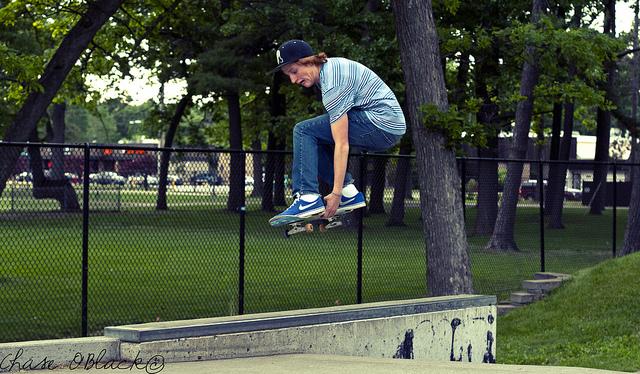Is this person's left or right foot closer to the grass?
Give a very brief answer. Left. Is he on the ground?
Keep it brief. No. Does the man look concerned?
Be succinct. No. What sport is being played?
Quick response, please. Skateboarding. What is the boy doing?
Give a very brief answer. Skateboarding. Is this man talking on a cell phone?
Short answer required. No. Which game is played here?
Short answer required. Skateboarding. 